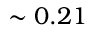Convert formula to latex. <formula><loc_0><loc_0><loc_500><loc_500>\sim 0 . 2 1 \</formula> 